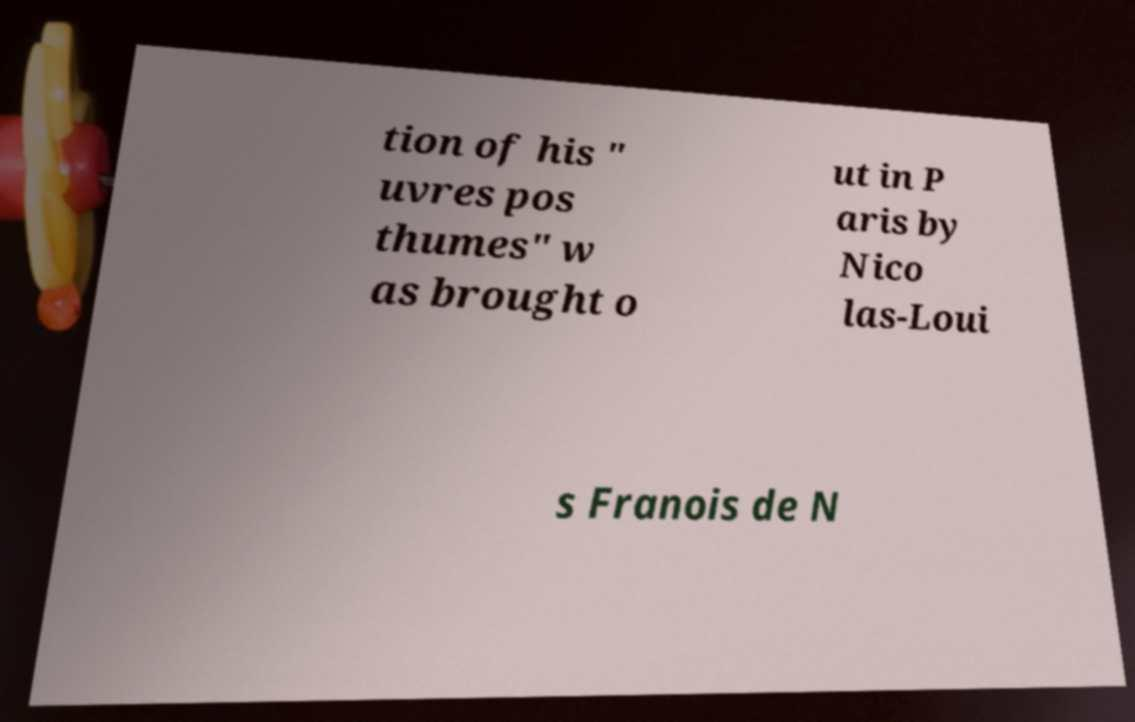Can you accurately transcribe the text from the provided image for me? tion of his " uvres pos thumes" w as brought o ut in P aris by Nico las-Loui s Franois de N 